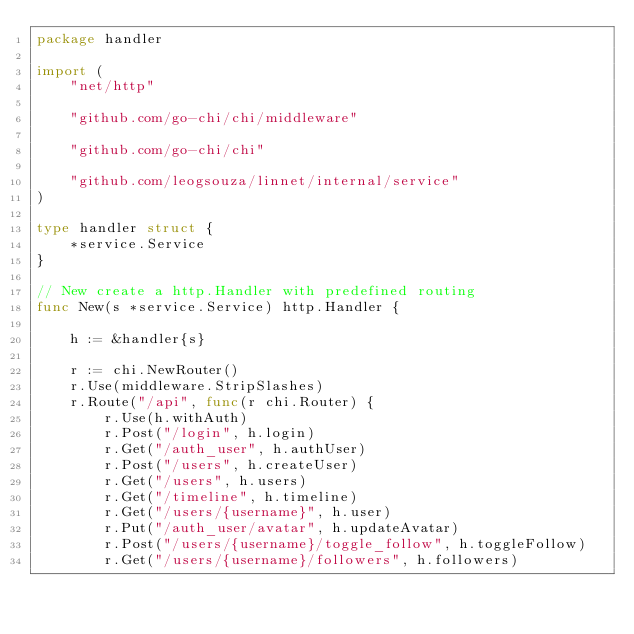<code> <loc_0><loc_0><loc_500><loc_500><_Go_>package handler

import (
	"net/http"

	"github.com/go-chi/chi/middleware"

	"github.com/go-chi/chi"

	"github.com/leogsouza/linnet/internal/service"
)

type handler struct {
	*service.Service
}

// New create a http.Handler with predefined routing
func New(s *service.Service) http.Handler {

	h := &handler{s}

	r := chi.NewRouter()
	r.Use(middleware.StripSlashes)
	r.Route("/api", func(r chi.Router) {
		r.Use(h.withAuth)
		r.Post("/login", h.login)
		r.Get("/auth_user", h.authUser)
		r.Post("/users", h.createUser)
		r.Get("/users", h.users)
		r.Get("/timeline", h.timeline)
		r.Get("/users/{username}", h.user)
		r.Put("/auth_user/avatar", h.updateAvatar)
		r.Post("/users/{username}/toggle_follow", h.toggleFollow)
		r.Get("/users/{username}/followers", h.followers)</code> 